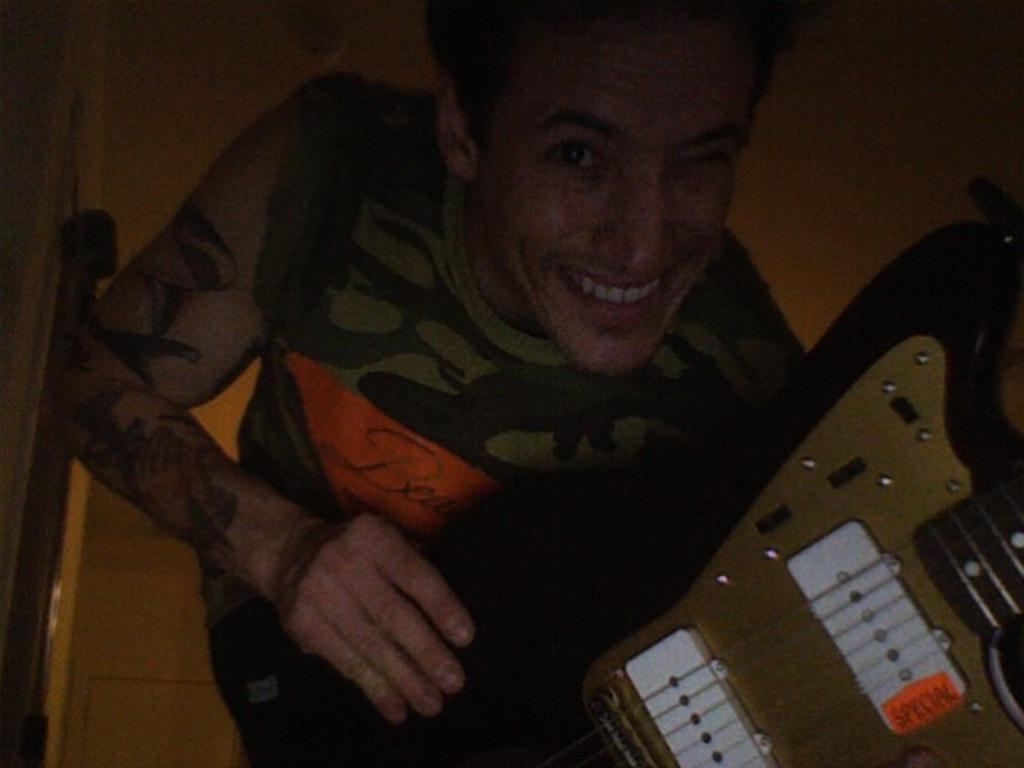How would you summarize this image in a sentence or two? In this picture there is a man who is holding a guitar and smiling. 